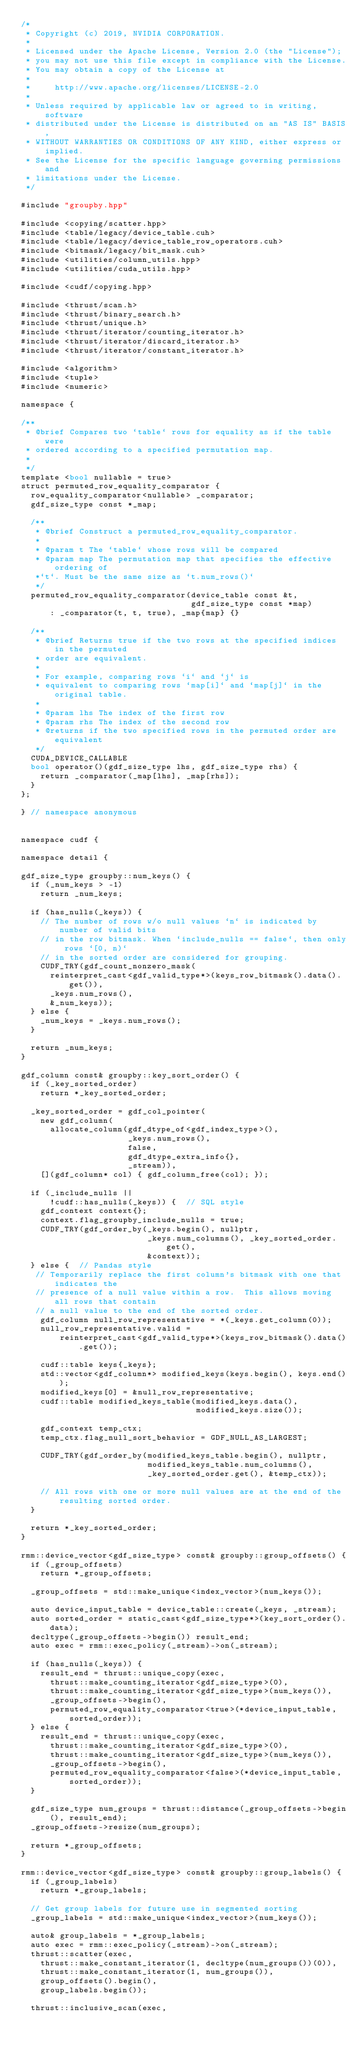Convert code to text. <code><loc_0><loc_0><loc_500><loc_500><_Cuda_>/*
 * Copyright (c) 2019, NVIDIA CORPORATION.
 *
 * Licensed under the Apache License, Version 2.0 (the "License");
 * you may not use this file except in compliance with the License.
 * You may obtain a copy of the License at
 *
 *     http://www.apache.org/licenses/LICENSE-2.0
 *
 * Unless required by applicable law or agreed to in writing, software
 * distributed under the License is distributed on an "AS IS" BASIS,
 * WITHOUT WARRANTIES OR CONDITIONS OF ANY KIND, either express or implied.
 * See the License for the specific language governing permissions and
 * limitations under the License.
 */

#include "groupby.hpp"

#include <copying/scatter.hpp>
#include <table/legacy/device_table.cuh>
#include <table/legacy/device_table_row_operators.cuh>
#include <bitmask/legacy/bit_mask.cuh>
#include <utilities/column_utils.hpp>
#include <utilities/cuda_utils.hpp>

#include <cudf/copying.hpp>

#include <thrust/scan.h>
#include <thrust/binary_search.h>
#include <thrust/unique.h>
#include <thrust/iterator/counting_iterator.h>
#include <thrust/iterator/discard_iterator.h>
#include <thrust/iterator/constant_iterator.h>

#include <algorithm>
#include <tuple>
#include <numeric>

namespace {

/**
 * @brief Compares two `table` rows for equality as if the table were
 * ordered according to a specified permutation map.
 *
 */
template <bool nullable = true>
struct permuted_row_equality_comparator {
  row_equality_comparator<nullable> _comparator;
  gdf_size_type const *_map;

  /**
   * @brief Construct a permuted_row_equality_comparator.
   *
   * @param t The `table` whose rows will be compared
   * @param map The permutation map that specifies the effective ordering of
   *`t`. Must be the same size as `t.num_rows()`
   */
  permuted_row_equality_comparator(device_table const &t,
                                   gdf_size_type const *map)
      : _comparator(t, t, true), _map{map} {}

  /**
   * @brief Returns true if the two rows at the specified indices in the permuted
   * order are equivalent.
   *
   * For example, comparing rows `i` and `j` is
   * equivalent to comparing rows `map[i]` and `map[j]` in the original table.
   *
   * @param lhs The index of the first row
   * @param rhs The index of the second row
   * @returns if the two specified rows in the permuted order are equivalent
   */
  CUDA_DEVICE_CALLABLE
  bool operator()(gdf_size_type lhs, gdf_size_type rhs) {
    return _comparator(_map[lhs], _map[rhs]);
  }
};

} // namespace anonymous


namespace cudf {

namespace detail {

gdf_size_type groupby::num_keys() {
  if (_num_keys > -1)
    return _num_keys;

  if (has_nulls(_keys)) {
    // The number of rows w/o null values `n` is indicated by number of valid bits
    // in the row bitmask. When `include_nulls == false`, then only rows `[0, n)` 
    // in the sorted order are considered for grouping. 
    CUDF_TRY(gdf_count_nonzero_mask(
      reinterpret_cast<gdf_valid_type*>(keys_row_bitmask().data().get()),
      _keys.num_rows(),
      &_num_keys));
  } else {
    _num_keys = _keys.num_rows();
  }

  return _num_keys; 
}

gdf_column const& groupby::key_sort_order() {
  if (_key_sorted_order)
    return *_key_sorted_order;

  _key_sorted_order = gdf_col_pointer(
    new gdf_column(
      allocate_column(gdf_dtype_of<gdf_index_type>(),
                      _keys.num_rows(),
                      false,
                      gdf_dtype_extra_info{},
                      _stream)),
    [](gdf_column* col) { gdf_column_free(col); });

  if (_include_nulls ||
      !cudf::has_nulls(_keys)) {  // SQL style
    gdf_context context{};
    context.flag_groupby_include_nulls = true;
    CUDF_TRY(gdf_order_by(_keys.begin(), nullptr,
                          _keys.num_columns(), _key_sorted_order.get(),
                          &context));
  } else {  // Pandas style
   // Temporarily replace the first column's bitmask with one that indicates the 
   // presence of a null value within a row.  This allows moving all rows that contain
   // a null value to the end of the sorted order. 
    gdf_column null_row_representative = *(_keys.get_column(0));
    null_row_representative.valid =
        reinterpret_cast<gdf_valid_type*>(keys_row_bitmask().data().get());

    cudf::table keys{_keys};
    std::vector<gdf_column*> modified_keys(keys.begin(), keys.end());
    modified_keys[0] = &null_row_representative;
    cudf::table modified_keys_table(modified_keys.data(),
                                    modified_keys.size());

    gdf_context temp_ctx;
    temp_ctx.flag_null_sort_behavior = GDF_NULL_AS_LARGEST;

    CUDF_TRY(gdf_order_by(modified_keys_table.begin(), nullptr,
                          modified_keys_table.num_columns(),
                          _key_sorted_order.get(), &temp_ctx));

    // All rows with one or more null values are at the end of the resulting sorted order.
  }

  return *_key_sorted_order;
}

rmm::device_vector<gdf_size_type> const& groupby::group_offsets() {
  if (_group_offsets)
    return *_group_offsets;

  _group_offsets = std::make_unique<index_vector>(num_keys());

  auto device_input_table = device_table::create(_keys, _stream);
  auto sorted_order = static_cast<gdf_size_type*>(key_sort_order().data);
  decltype(_group_offsets->begin()) result_end;
  auto exec = rmm::exec_policy(_stream)->on(_stream);

  if (has_nulls(_keys)) {
    result_end = thrust::unique_copy(exec,
      thrust::make_counting_iterator<gdf_size_type>(0),
      thrust::make_counting_iterator<gdf_size_type>(num_keys()),
      _group_offsets->begin(),
      permuted_row_equality_comparator<true>(*device_input_table, sorted_order));
  } else {
    result_end = thrust::unique_copy(exec, 
      thrust::make_counting_iterator<gdf_size_type>(0),
      thrust::make_counting_iterator<gdf_size_type>(num_keys()),
      _group_offsets->begin(),
      permuted_row_equality_comparator<false>(*device_input_table, sorted_order));
  }

  gdf_size_type num_groups = thrust::distance(_group_offsets->begin(), result_end);
  _group_offsets->resize(num_groups);

  return *_group_offsets;
}

rmm::device_vector<gdf_size_type> const& groupby::group_labels() {
  if (_group_labels)
    return *_group_labels;

  // Get group labels for future use in segmented sorting
  _group_labels = std::make_unique<index_vector>(num_keys());

  auto& group_labels = *_group_labels;
  auto exec = rmm::exec_policy(_stream)->on(_stream);
  thrust::scatter(exec,
    thrust::make_constant_iterator(1, decltype(num_groups())(0)), 
    thrust::make_constant_iterator(1, num_groups()), 
    group_offsets().begin(), 
    group_labels.begin());
 
  thrust::inclusive_scan(exec,</code> 